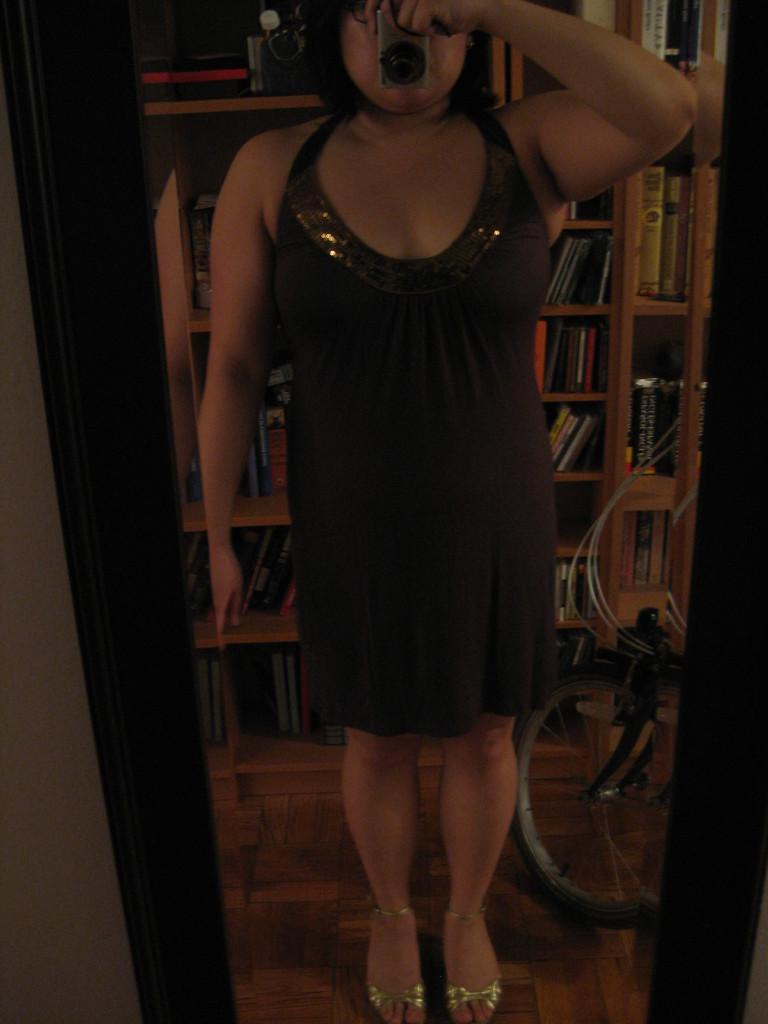Can you describe this image briefly? This picture shows a mirror and we see reflection of a woman standing and holding a camera in her hand and we see a bicycle wheel and a bookshelf with books on the back. 